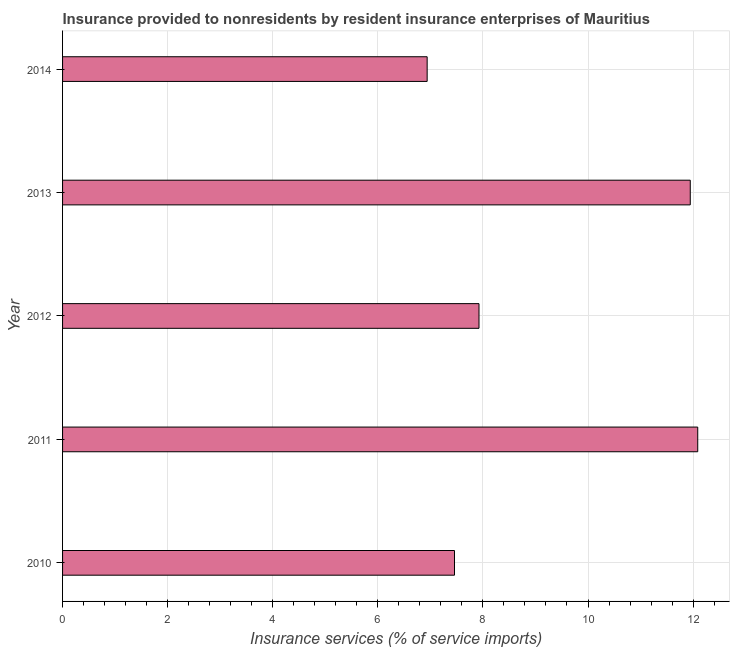Does the graph contain any zero values?
Provide a short and direct response. No. What is the title of the graph?
Keep it short and to the point. Insurance provided to nonresidents by resident insurance enterprises of Mauritius. What is the label or title of the X-axis?
Your answer should be very brief. Insurance services (% of service imports). What is the label or title of the Y-axis?
Provide a succinct answer. Year. What is the insurance and financial services in 2013?
Make the answer very short. 11.95. Across all years, what is the maximum insurance and financial services?
Give a very brief answer. 12.09. Across all years, what is the minimum insurance and financial services?
Ensure brevity in your answer.  6.94. What is the sum of the insurance and financial services?
Offer a very short reply. 46.36. What is the difference between the insurance and financial services in 2013 and 2014?
Keep it short and to the point. 5.01. What is the average insurance and financial services per year?
Ensure brevity in your answer.  9.27. What is the median insurance and financial services?
Provide a short and direct response. 7.93. In how many years, is the insurance and financial services greater than 6.4 %?
Keep it short and to the point. 5. What is the ratio of the insurance and financial services in 2010 to that in 2012?
Offer a very short reply. 0.94. Is the insurance and financial services in 2011 less than that in 2014?
Your answer should be very brief. No. Is the difference between the insurance and financial services in 2012 and 2013 greater than the difference between any two years?
Keep it short and to the point. No. What is the difference between the highest and the second highest insurance and financial services?
Offer a very short reply. 0.14. Is the sum of the insurance and financial services in 2010 and 2013 greater than the maximum insurance and financial services across all years?
Provide a short and direct response. Yes. What is the difference between the highest and the lowest insurance and financial services?
Your answer should be compact. 5.15. In how many years, is the insurance and financial services greater than the average insurance and financial services taken over all years?
Ensure brevity in your answer.  2. What is the Insurance services (% of service imports) of 2010?
Your answer should be very brief. 7.46. What is the Insurance services (% of service imports) of 2011?
Keep it short and to the point. 12.09. What is the Insurance services (% of service imports) in 2012?
Provide a short and direct response. 7.93. What is the Insurance services (% of service imports) in 2013?
Provide a short and direct response. 11.95. What is the Insurance services (% of service imports) of 2014?
Ensure brevity in your answer.  6.94. What is the difference between the Insurance services (% of service imports) in 2010 and 2011?
Your answer should be very brief. -4.63. What is the difference between the Insurance services (% of service imports) in 2010 and 2012?
Your answer should be very brief. -0.47. What is the difference between the Insurance services (% of service imports) in 2010 and 2013?
Keep it short and to the point. -4.49. What is the difference between the Insurance services (% of service imports) in 2010 and 2014?
Make the answer very short. 0.52. What is the difference between the Insurance services (% of service imports) in 2011 and 2012?
Provide a succinct answer. 4.16. What is the difference between the Insurance services (% of service imports) in 2011 and 2013?
Your answer should be very brief. 0.14. What is the difference between the Insurance services (% of service imports) in 2011 and 2014?
Your response must be concise. 5.15. What is the difference between the Insurance services (% of service imports) in 2012 and 2013?
Your answer should be compact. -4.02. What is the difference between the Insurance services (% of service imports) in 2012 and 2014?
Offer a terse response. 0.99. What is the difference between the Insurance services (% of service imports) in 2013 and 2014?
Give a very brief answer. 5.01. What is the ratio of the Insurance services (% of service imports) in 2010 to that in 2011?
Make the answer very short. 0.62. What is the ratio of the Insurance services (% of service imports) in 2010 to that in 2012?
Your answer should be very brief. 0.94. What is the ratio of the Insurance services (% of service imports) in 2010 to that in 2013?
Your answer should be very brief. 0.62. What is the ratio of the Insurance services (% of service imports) in 2010 to that in 2014?
Provide a succinct answer. 1.07. What is the ratio of the Insurance services (% of service imports) in 2011 to that in 2012?
Keep it short and to the point. 1.52. What is the ratio of the Insurance services (% of service imports) in 2011 to that in 2013?
Provide a short and direct response. 1.01. What is the ratio of the Insurance services (% of service imports) in 2011 to that in 2014?
Your answer should be compact. 1.74. What is the ratio of the Insurance services (% of service imports) in 2012 to that in 2013?
Ensure brevity in your answer.  0.66. What is the ratio of the Insurance services (% of service imports) in 2012 to that in 2014?
Give a very brief answer. 1.14. What is the ratio of the Insurance services (% of service imports) in 2013 to that in 2014?
Your answer should be very brief. 1.72. 